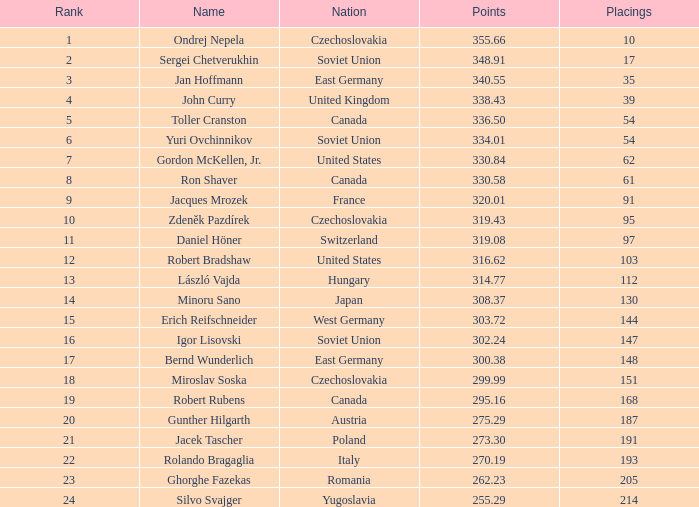In which nation can we find 30 East Germany. 